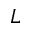Convert formula to latex. <formula><loc_0><loc_0><loc_500><loc_500>L</formula> 